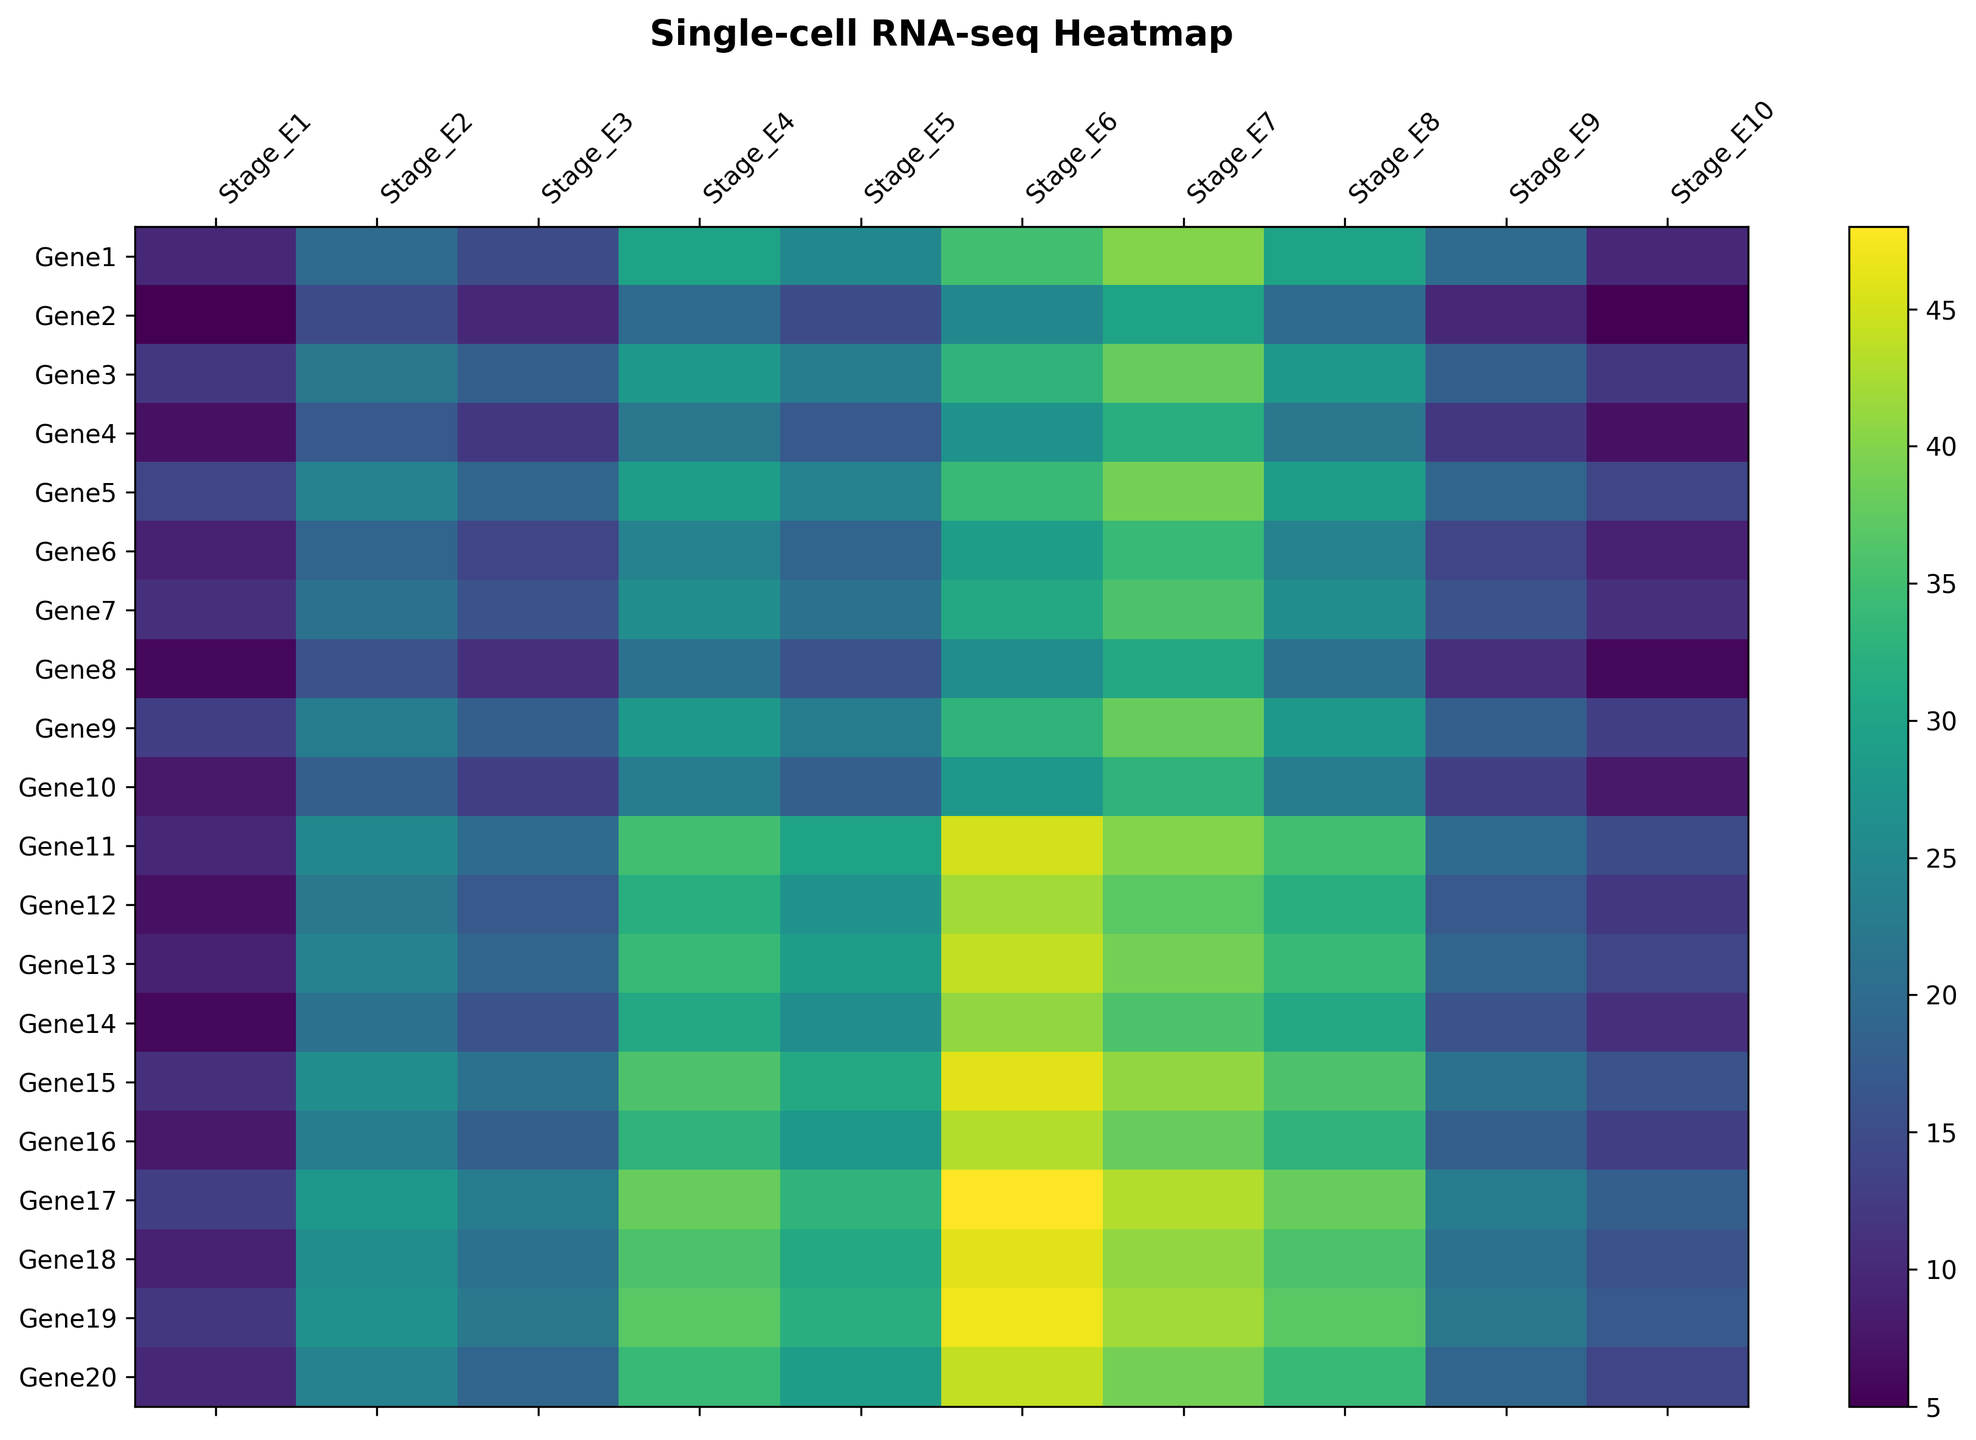What is the highest expression value observed for Gene1, and at which stage does it occur? To find the highest expression value for Gene1, we look through its expression values across all stages and identify the maximum value. Gene1 has expression values [10, 20, 15, 30, 25, 35, 40, 30, 20, 10]. The maximum value is 40, which occurs at Stage_E7.
Answer: 40, Stage_E7 Which gene shows the most significant increase in expression from Stage_E1 to Stage_E10? To determine which gene shows the most significant increase, we need to compare the difference between the expression values at Stage_E1 and Stage_E10 for all genes. By calculating these differences for each gene, the gene with the highest positive difference will be the answer. Most significant increase is observed for Gene17 with an increase of 5 units from 13 at Stage_E1 to 18 at Stage_E10.
Answer: Gene17 What is the average expression value for Gene5 across all stages? To find the average expression value for Gene5, we add up its expression values across all stages and divide by the number of stages. Gene5's expressions are [14, 24, 19, 29, 24, 34, 39, 29, 19, 14]. The sum is 245, and there are 10 stages, so the average is 245/10 = 24.5.
Answer: 24.5 Which stage shows the highest average expression value across all genes? To find this, we need to calculate the average expression value for each stage by summing up the expression values of all genes at each stage and then dividing by the number of genes. Stage_E6 has the highest average expression value. Summing up numbers at Stage_E6 gives 583, dividing by 20 genes gives an average of 29.15.
Answer: Stage_E6 Between Gene3 and Gene8, which gene has a higher expression value at Stage_E5? To compare the expression values of Gene3 and Gene8 at Stage_E5, we look at their expression values at that stage. Gene3's expression at Stage_E5 is 23, and Gene8's is 16. Gene3 has the higher value.
Answer: Gene3 Is there a gene whose expression value consistently increases from Stage_E1 to Stage_E10? Investigate each gene individually to check if the expression values consistently increase across the stages from Stage_E1 to Stage_E10. No gene in the provided data consistently increases from Stage_E1 to Stage_E10.
Answer: No What is the difference in expression values of Gene10 between Stage_E7 and Stage_E9? To find the difference, subtract the expression value of Gene10 at Stage_E9 from that at Stage_E7. Gene10’s expression at Stage_E7 is 33, and at Stage_E9 is 13. The difference is 33 - 13 which is 20.
Answer: 20 Which stage has the lowest expression value for Gene14, and what is that value? Look through the expression values of Gene14 across all stages to find the minimum value and the corresponding stage. Gene14 has the lowest value of 6 at Stage_E1.
Answer: Stage_E1, 6 How does the expression of Gene20 change from Stage_E2 to Stage_E4? Compare the expression values of Gene20 at Stage_E2 and Stage_E4. Gene20’s expression at Stage_E2 is 24, and at Stage_E4 is 34. This indicates an increase of 10 units.
Answer: Increases by 10 